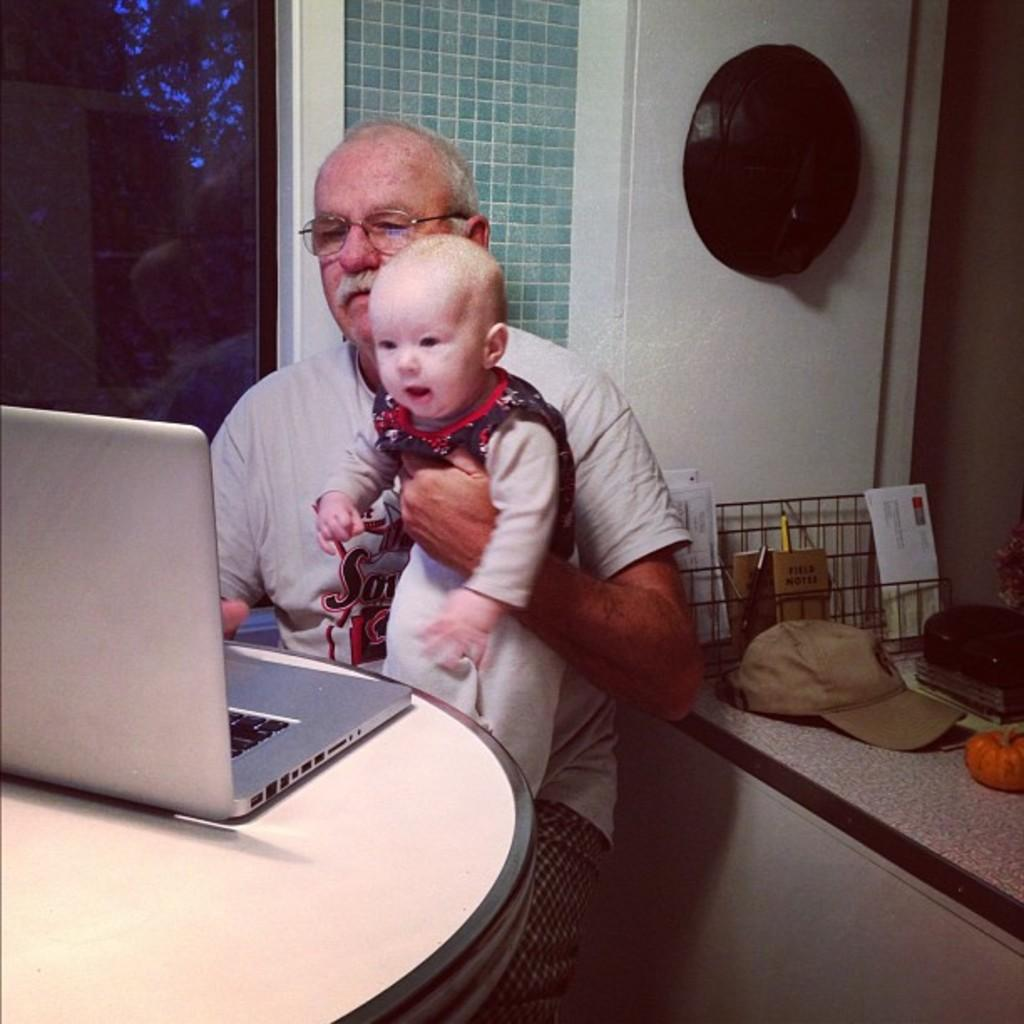What is the man in the image doing? The man is holding a kid in the image. What object can be seen on a table in the image? There is a laptop on a table in the image. What can be seen in the background of the image? There is a window, a wall, and a cap in the background of the image. What type of wound can be seen on the man's face in the image? There is no wound visible on the man's face in the image. What is the man's opinion about the cap in the background of the image? The image does not provide any information about the man's opinion on the cap or any other object in the image. 